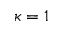<formula> <loc_0><loc_0><loc_500><loc_500>\kappa = 1</formula> 